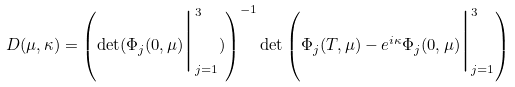Convert formula to latex. <formula><loc_0><loc_0><loc_500><loc_500>D ( \mu , \kappa ) = \left ( \det ( \Phi _ { j } ( 0 , \mu ) \Big { | } _ { j = 1 } ^ { 3 } ) \right ) ^ { - 1 } \det \left ( \Phi _ { j } ( T , \mu ) - e ^ { i \kappa } \Phi _ { j } ( 0 , \mu ) \Big { | } _ { j = 1 } ^ { 3 } \right )</formula> 